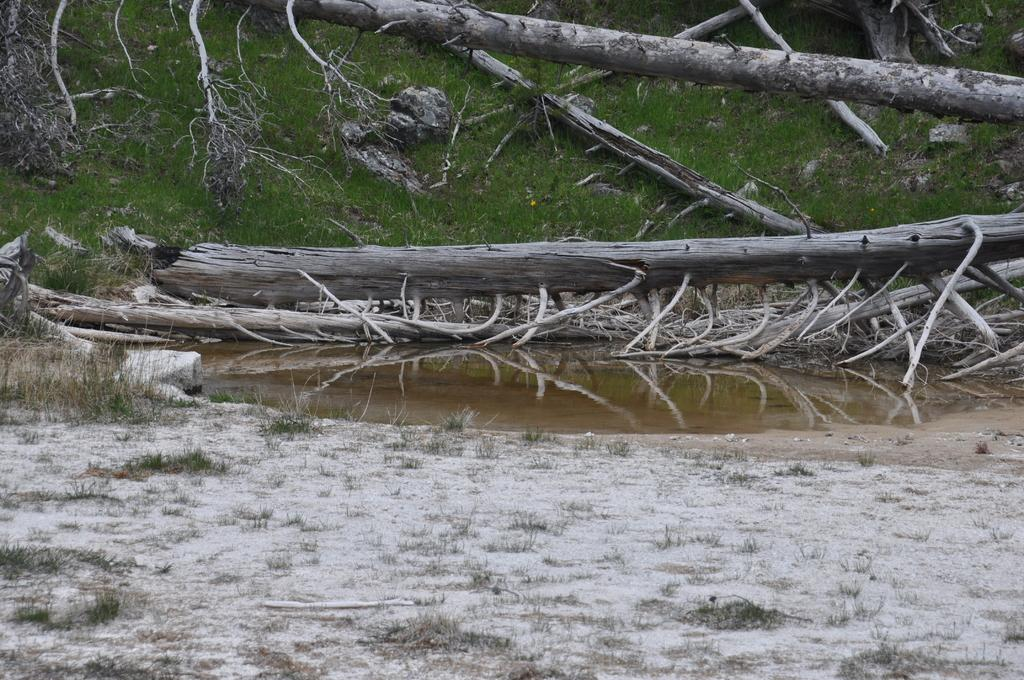What type of vegetation can be seen in the image? There is grass in the image. What else can be seen in the image besides grass? There are branches visible in the image. What natural element is present in the image? There is water visible in the image. What type of linen can be seen draped over the branches in the image? There is no linen present in the image; it only features grass, branches, and water. 